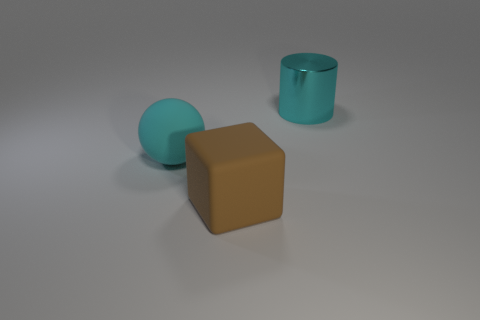Add 2 large rubber blocks. How many objects exist? 5 Subtract all spheres. How many objects are left? 2 Add 1 tiny green spheres. How many tiny green spheres exist? 1 Subtract 0 purple cylinders. How many objects are left? 3 Subtract all large brown objects. Subtract all cyan objects. How many objects are left? 0 Add 3 shiny things. How many shiny things are left? 4 